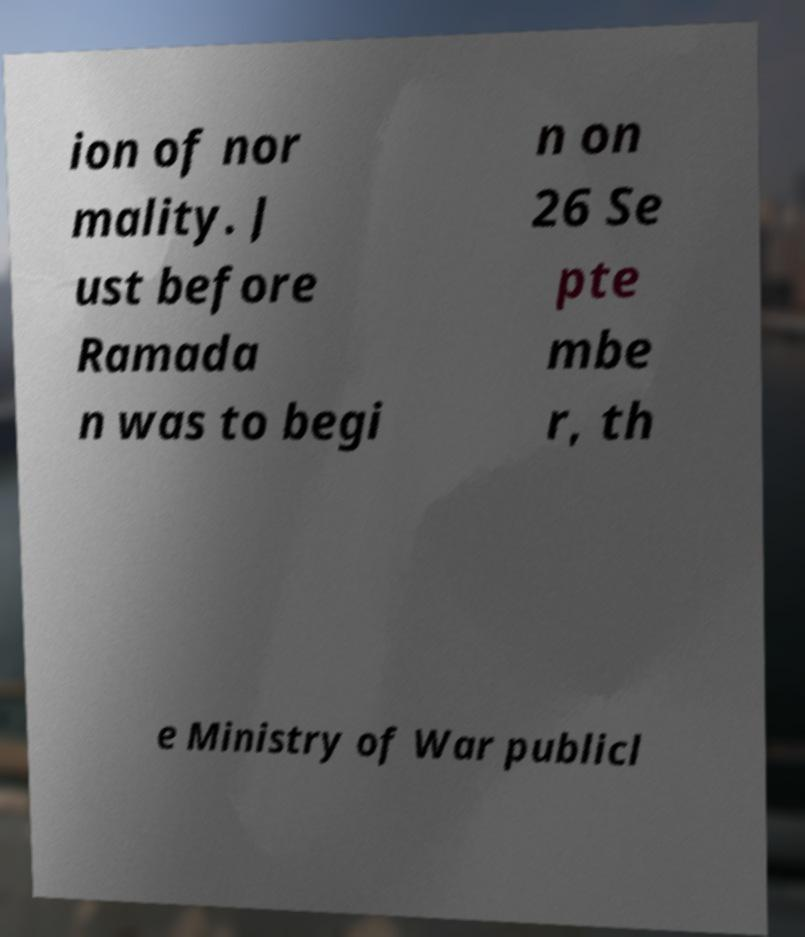For documentation purposes, I need the text within this image transcribed. Could you provide that? ion of nor mality. J ust before Ramada n was to begi n on 26 Se pte mbe r, th e Ministry of War publicl 